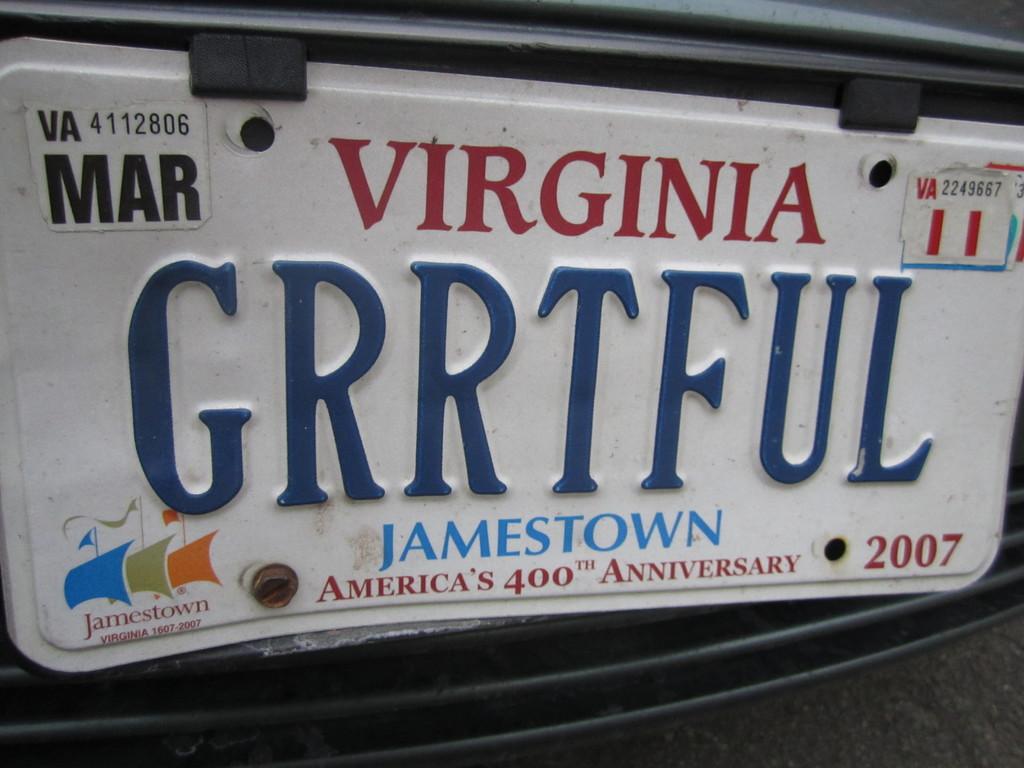Which state was the plate issued for ?
Ensure brevity in your answer.  Virginia. What month is the registration on the license plate?
Ensure brevity in your answer.  March. 